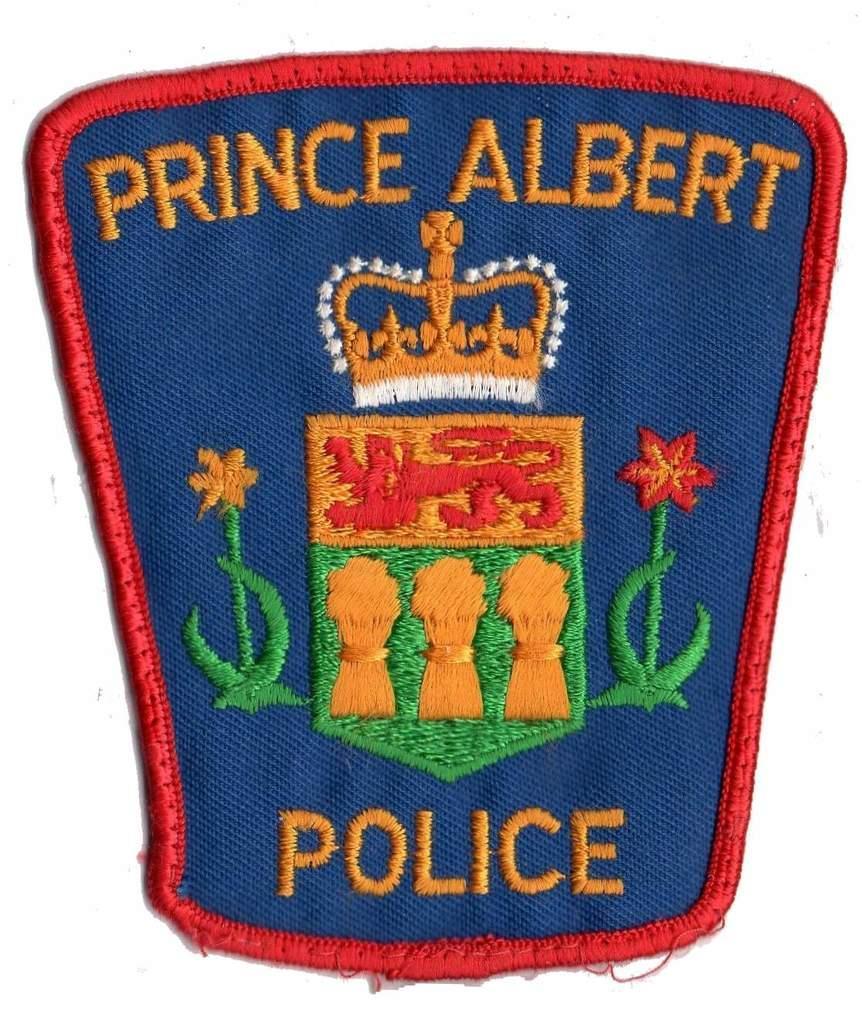How would you summarize this image in a sentence or two? In this image I can see the badge which is colorful and something is written on the badge. I can see the white background. 